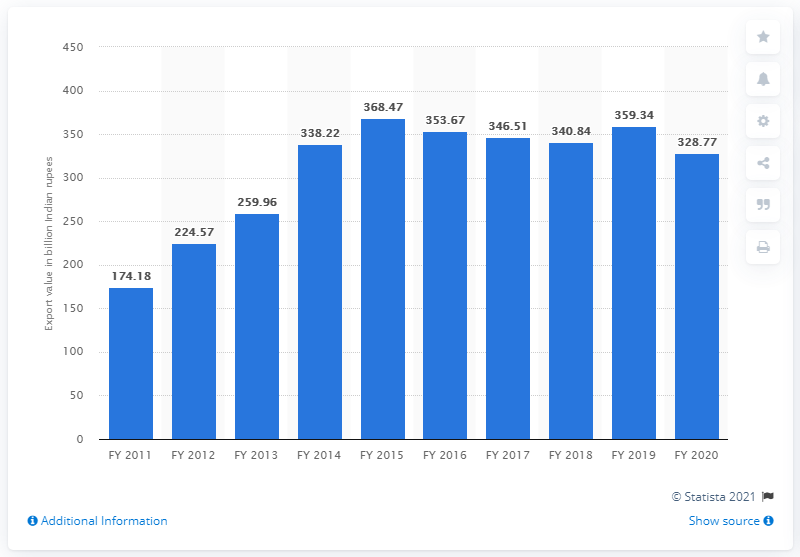Outline some significant characteristics in this image. In the fiscal year of 2020, the value of leather and leather products exported from India was 328.77. In the previous year, the value of leather and leather product exports from India was 359.34 million USD. 